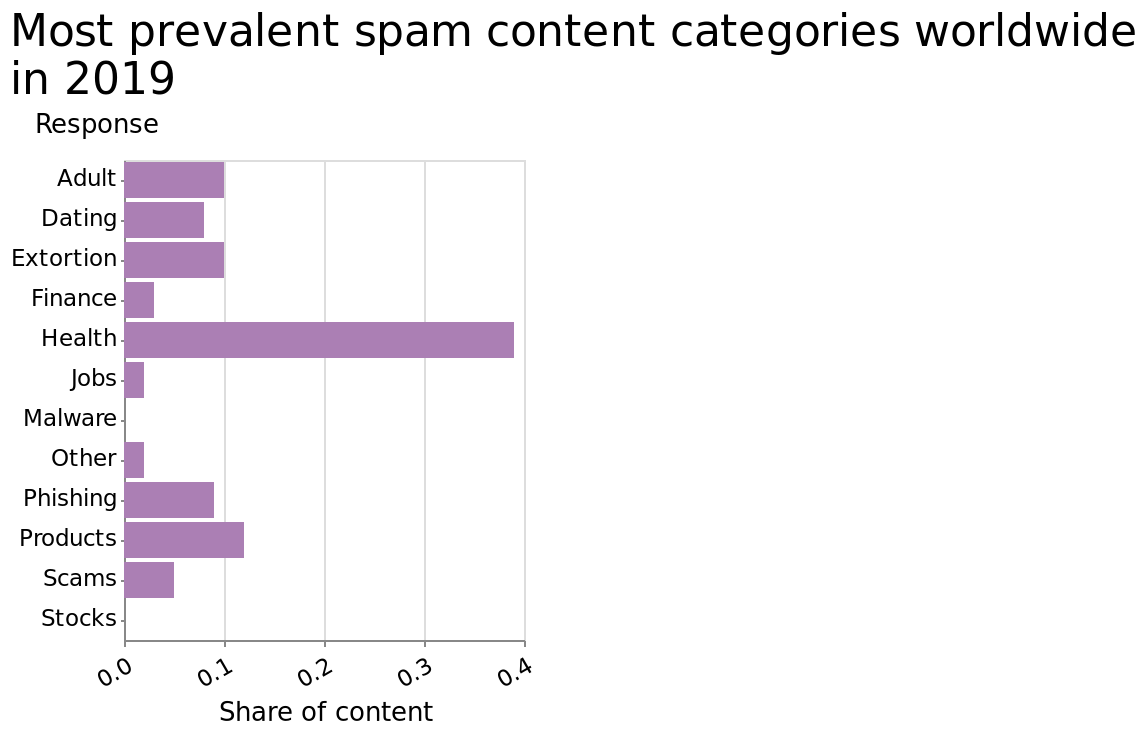<image>
Offer a thorough analysis of the image. The largest Spam catagory shared worldwide was Health. Scam Spam was minimal compared to Extortion Spam. Whilst Adult and dating saw a similar but not equallevel of spam content worldwide. What are the two extreme categories represented on the y-axis? The two extreme categories represented on the y-axis are Adult and Stocks. How does the amount of Scam Spam compare to Extortion Spam? Scam Spam was minimal compared to Extortion Spam. 